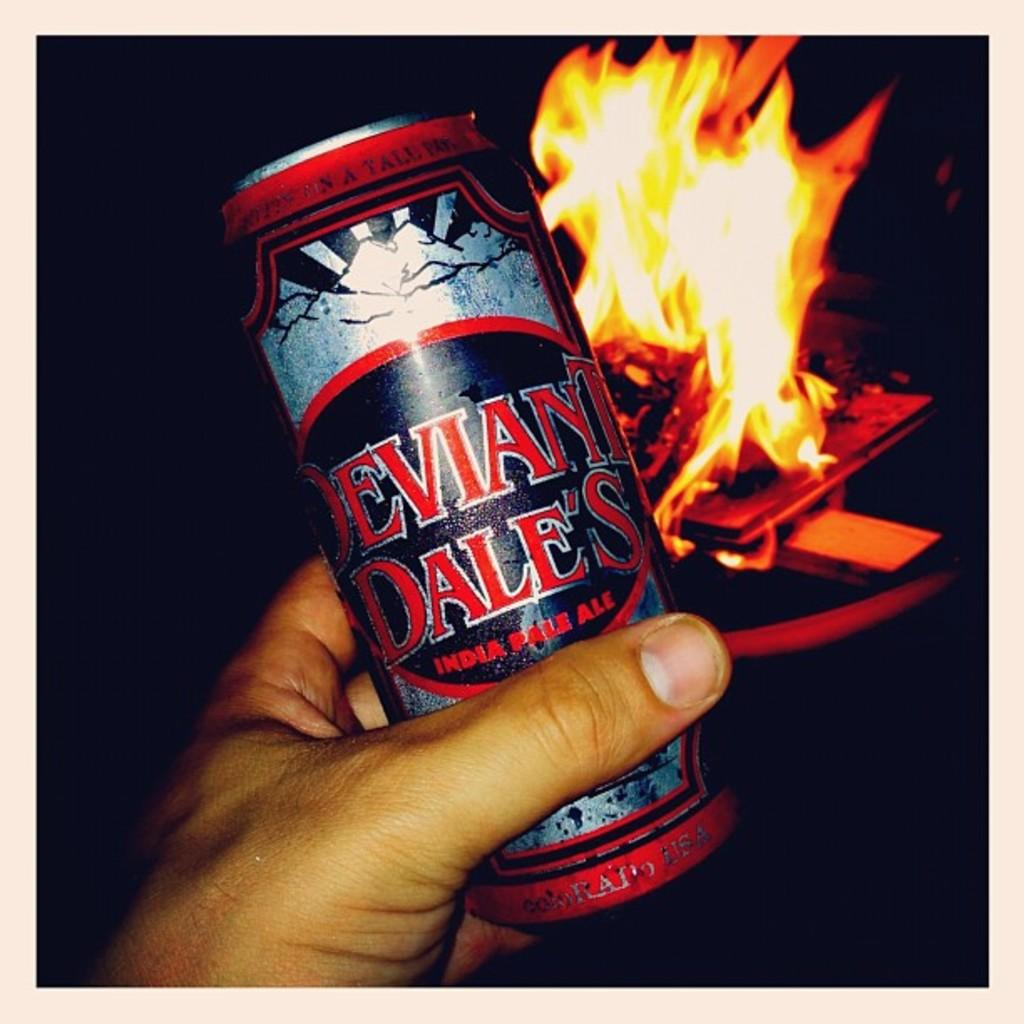<image>
Provide a brief description of the given image. A hand holding a can of Deviant Dale's IPA. 